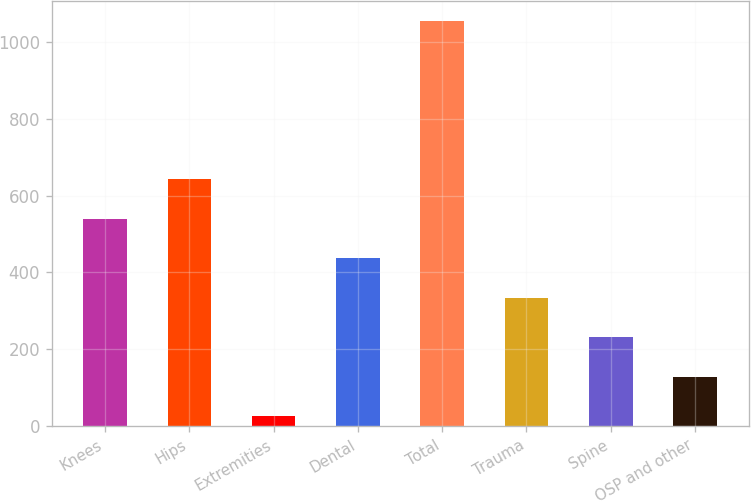Convert chart to OTSL. <chart><loc_0><loc_0><loc_500><loc_500><bar_chart><fcel>Knees<fcel>Hips<fcel>Extremities<fcel>Dental<fcel>Total<fcel>Trauma<fcel>Spine<fcel>OSP and other<nl><fcel>540.15<fcel>643.02<fcel>25.8<fcel>437.28<fcel>1054.5<fcel>334.41<fcel>231.54<fcel>128.67<nl></chart> 